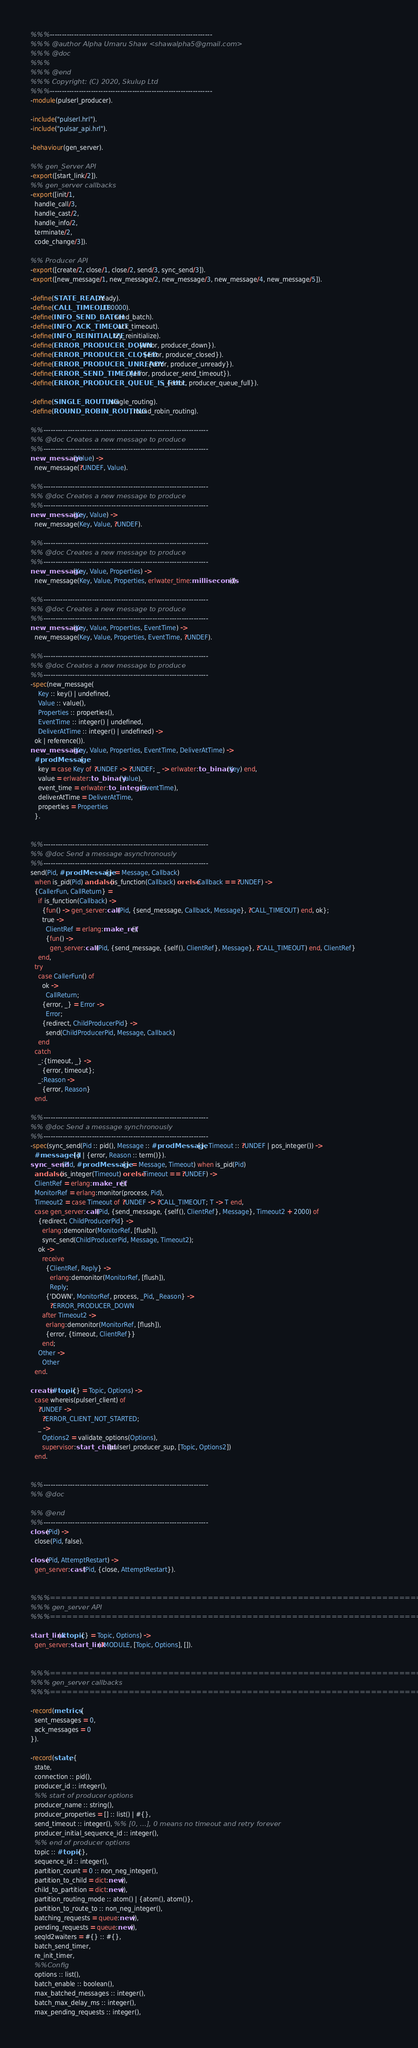Convert code to text. <code><loc_0><loc_0><loc_500><loc_500><_Erlang_>%%%-------------------------------------------------------------------
%%% @author Alpha Umaru Shaw <shawalpha5@gmail.com>
%%% @doc
%%%
%%% @end
%%% Copyright: (C) 2020, Skulup Ltd
%%%-------------------------------------------------------------------
-module(pulserl_producer).

-include("pulserl.hrl").
-include("pulsar_api.hrl").

-behaviour(gen_server).

%% gen_Server API
-export([start_link/2]).
%% gen_server callbacks
-export([init/1,
  handle_call/3,
  handle_cast/2,
  handle_info/2,
  terminate/2,
  code_change/3]).

%% Producer API
-export([create/2, close/1, close/2, send/3, sync_send/3]).
-export([new_message/1, new_message/2, new_message/3, new_message/4, new_message/5]).

-define(STATE_READY, ready).
-define(CALL_TIMEOUT, 180000).
-define(INFO_SEND_BATCH, send_batch).
-define(INFO_ACK_TIMEOUT, ack_timeout).
-define(INFO_REINITIALIZE, try_reinitialize).
-define(ERROR_PRODUCER_DOWN, {error, producer_down}).
-define(ERROR_PRODUCER_CLOSED, {error, producer_closed}).
-define(ERROR_PRODUCER_UNREADY, {error, producer_unready}).
-define(ERROR_SEND_TIMEOUT, {error, producer_send_timeout}).
-define(ERROR_PRODUCER_QUEUE_IS_FULL, {error, producer_queue_full}).

-define(SINGLE_ROUTING, single_routing).
-define(ROUND_ROBIN_ROUTING, round_robin_routing).

%%--------------------------------------------------------------------
%% @doc Creates a new message to produce
%%--------------------------------------------------------------------
new_message(Value) ->
  new_message(?UNDEF, Value).

%%--------------------------------------------------------------------
%% @doc Creates a new message to produce
%%--------------------------------------------------------------------
new_message(Key, Value) ->
  new_message(Key, Value, ?UNDEF).

%%--------------------------------------------------------------------
%% @doc Creates a new message to produce
%%--------------------------------------------------------------------
new_message(Key, Value, Properties) ->
  new_message(Key, Value, Properties, erlwater_time:milliseconds()).

%%--------------------------------------------------------------------
%% @doc Creates a new message to produce
%%--------------------------------------------------------------------
new_message(Key, Value, Properties, EventTime) ->
  new_message(Key, Value, Properties, EventTime, ?UNDEF).

%%--------------------------------------------------------------------
%% @doc Creates a new message to produce
%%--------------------------------------------------------------------
-spec(new_message(
    Key :: key() | undefined,
    Value :: value(),
    Properties :: properties(),
    EventTime :: integer() | undefined,
    DeliverAtTime :: integer() | undefined) ->
  ok | reference()).
new_message(Key, Value, Properties, EventTime, DeliverAtTime) ->
  #prodMessage{
    key = case Key of ?UNDEF -> ?UNDEF; _ -> erlwater:to_binary(Key) end,
    value = erlwater:to_binary(Value),
    event_time = erlwater:to_integer(EventTime),
    deliverAtTime = DeliverAtTime,
    properties = Properties
  }.


%%--------------------------------------------------------------------
%% @doc Send a message asynchronously
%%--------------------------------------------------------------------
send(Pid, #prodMessage{} = Message, Callback)
  when is_pid(Pid) andalso (is_function(Callback) orelse Callback == ?UNDEF) ->
  {CallerFun, CallReturn} =
    if is_function(Callback) ->
      {fun() -> gen_server:call(Pid, {send_message, Callback, Message}, ?CALL_TIMEOUT) end, ok};
      true ->
        ClientRef = erlang:make_ref(),
        {fun() ->
          gen_server:call(Pid, {send_message, {self(), ClientRef}, Message}, ?CALL_TIMEOUT) end, ClientRef}
    end,
  try
    case CallerFun() of
      ok ->
        CallReturn;
      {error, _} = Error ->
        Error;
      {redirect, ChildProducerPid} ->
        send(ChildProducerPid, Message, Callback)
    end
  catch
    _:{timeout, _} ->
      {error, timeout};
    _:Reason ->
      {error, Reason}
  end.

%%--------------------------------------------------------------------
%% @doc Send a message synchronously
%%--------------------------------------------------------------------
-spec(sync_send(Pid :: pid(), Message :: #prodMessage{}, Timeout :: ?UNDEF | pos_integer()) ->
  #messageId{} | {error, Reason :: term()}).
sync_send(Pid, #prodMessage{} = Message, Timeout) when is_pid(Pid)
  andalso (is_integer(Timeout) orelse Timeout == ?UNDEF) ->
  ClientRef = erlang:make_ref(),
  MonitorRef = erlang:monitor(process, Pid),
  Timeout2 = case Timeout of ?UNDEF -> ?CALL_TIMEOUT; T -> T end,
  case gen_server:call(Pid, {send_message, {self(), ClientRef}, Message}, Timeout2 + 2000) of
    {redirect, ChildProducerPid} ->
      erlang:demonitor(MonitorRef, [flush]),
      sync_send(ChildProducerPid, Message, Timeout2);
    ok ->
      receive
        {ClientRef, Reply} ->
          erlang:demonitor(MonitorRef, [flush]),
          Reply;
        {'DOWN', MonitorRef, process, _Pid, _Reason} ->
          ?ERROR_PRODUCER_DOWN
      after Timeout2 ->
        erlang:demonitor(MonitorRef, [flush]),
        {error, {timeout, ClientRef}}
      end;
    Other ->
      Other
  end.

create(#topic{} = Topic, Options) ->
  case whereis(pulserl_client) of
    ?UNDEF ->
      ?ERROR_CLIENT_NOT_STARTED;
    _ ->
      Options2 = validate_options(Options),
      supervisor:start_child(pulserl_producer_sup, [Topic, Options2])
  end.


%%--------------------------------------------------------------------
%% @doc

%% @end
%%--------------------------------------------------------------------
close(Pid) ->
  close(Pid, false).

close(Pid, AttemptRestart) ->
  gen_server:cast(Pid, {close, AttemptRestart}).


%%%===================================================================
%%% gen_server API
%%%===================================================================

start_link(#topic{} = Topic, Options) ->
  gen_server:start_link(?MODULE, [Topic, Options], []).


%%%===================================================================
%%% gen_server callbacks
%%%===================================================================

-record(metrics, {
  sent_messages = 0,
  ack_messages = 0
}).

-record(state, {
  state,
  connection :: pid(),
  producer_id :: integer(),
  %% start of producer options
  producer_name :: string(),
  producer_properties = [] :: list() | #{},
  send_timeout :: integer(), %% [0, ...], 0 means no timeout and retry forever
  producer_initial_sequence_id :: integer(),
  %% end of producer options
  topic :: #topic{},
  sequence_id :: integer(),
  partition_count = 0 :: non_neg_integer(),
  partition_to_child = dict:new(),
  child_to_partition = dict:new(),
  partition_routing_mode :: atom() | {atom(), atom()},
  partition_to_route_to :: non_neg_integer(),
  batching_requests = queue:new(),
  pending_requests = queue:new(),
  seqId2waiters = #{} :: #{},
  batch_send_timer,
  re_init_timer,
  %%Config
  options :: list(),
  batch_enable :: boolean(),
  max_batched_messages :: integer(),
  batch_max_delay_ms :: integer(),
  max_pending_requests :: integer(),</code> 